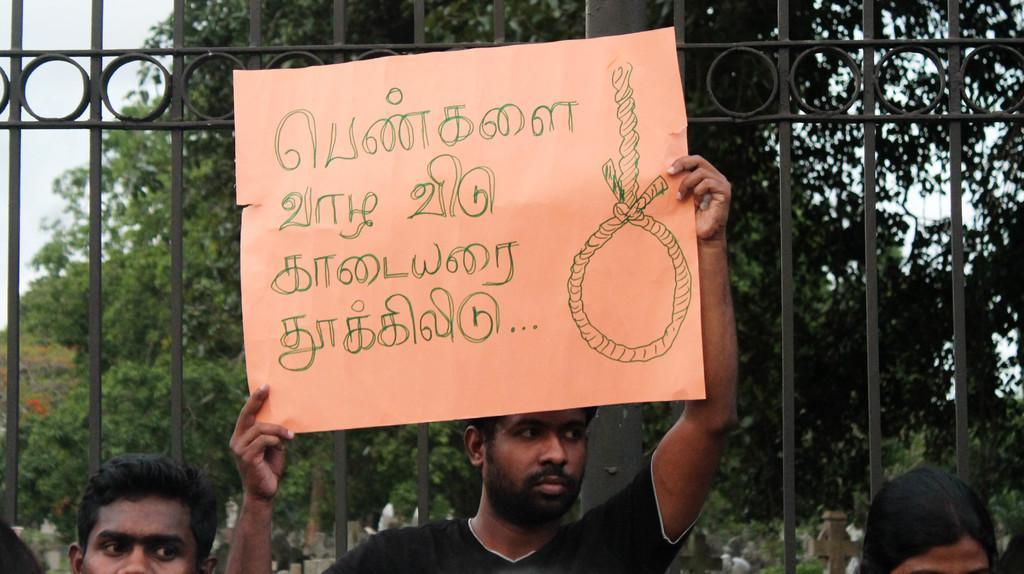In one or two sentences, can you explain what this image depicts? In this image I can see the person is holding the chart and something is written on it. I can see few people, trees, sky and the iron gate. 